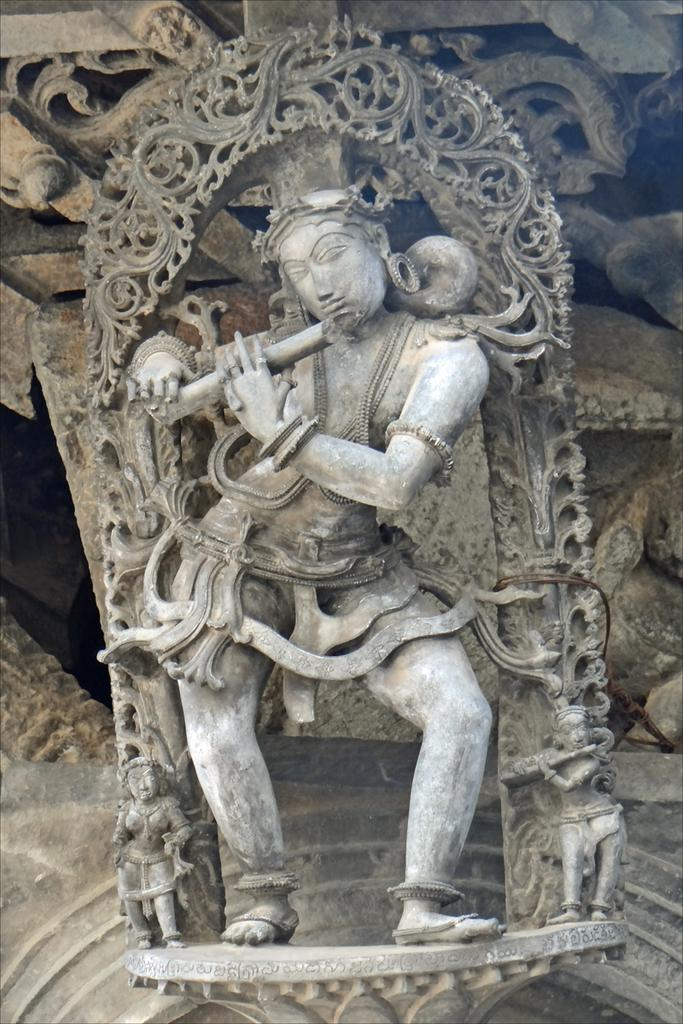What is the main subject of the image? There is a sculpture in the image. What type of weather can be seen in the image? There is no information about the weather in the image, as it only features a sculpture. Is there a prison visible in the image? No, there is no prison present in the image; it only features a sculpture. 